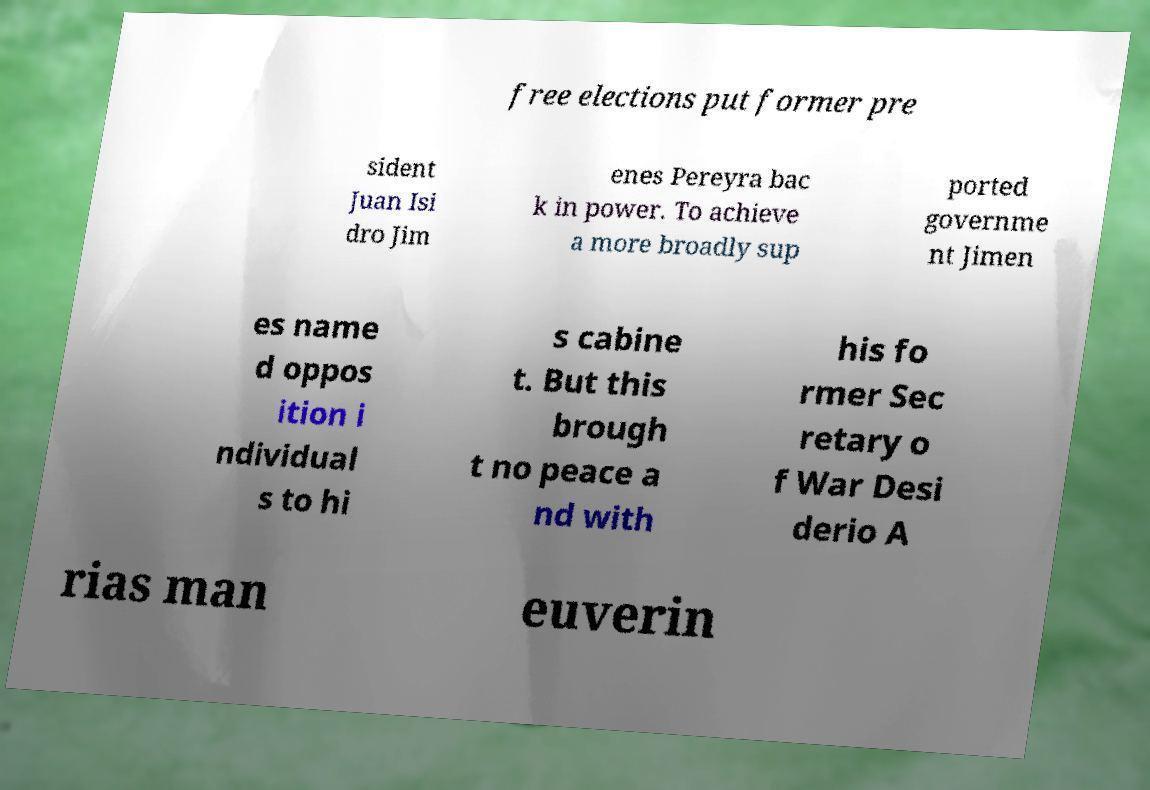Could you assist in decoding the text presented in this image and type it out clearly? free elections put former pre sident Juan Isi dro Jim enes Pereyra bac k in power. To achieve a more broadly sup ported governme nt Jimen es name d oppos ition i ndividual s to hi s cabine t. But this brough t no peace a nd with his fo rmer Sec retary o f War Desi derio A rias man euverin 